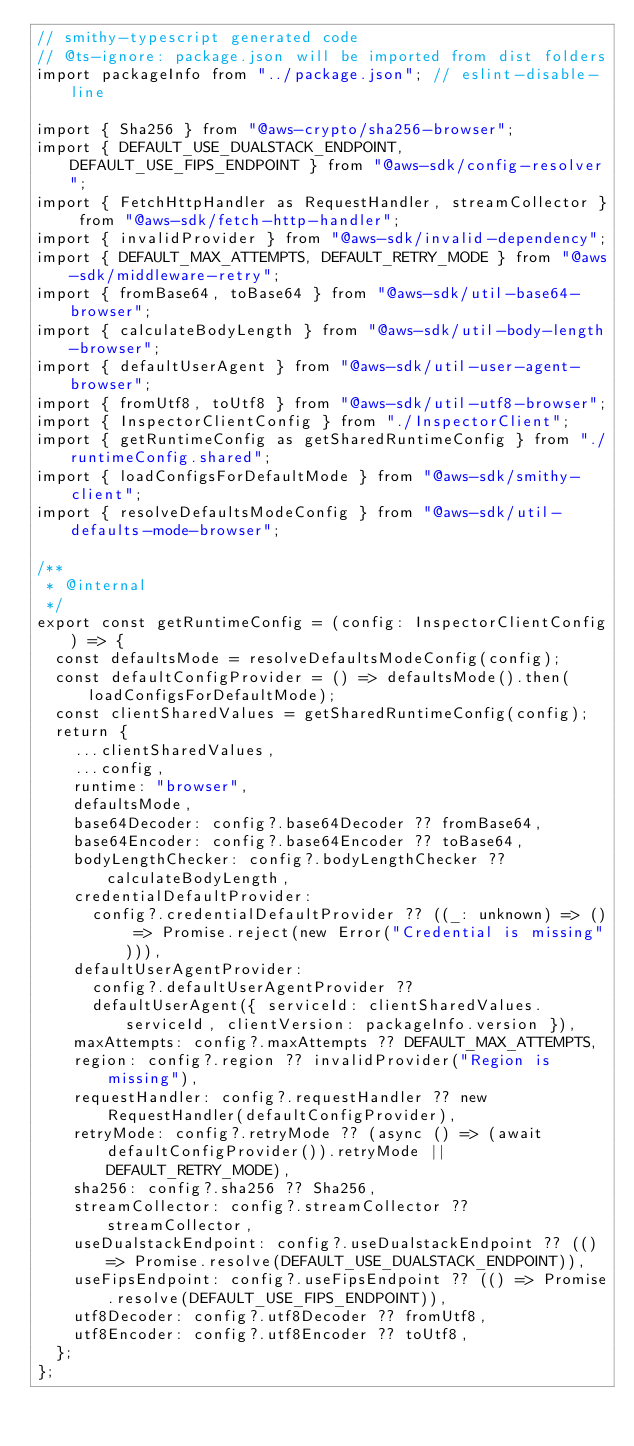<code> <loc_0><loc_0><loc_500><loc_500><_TypeScript_>// smithy-typescript generated code
// @ts-ignore: package.json will be imported from dist folders
import packageInfo from "../package.json"; // eslint-disable-line

import { Sha256 } from "@aws-crypto/sha256-browser";
import { DEFAULT_USE_DUALSTACK_ENDPOINT, DEFAULT_USE_FIPS_ENDPOINT } from "@aws-sdk/config-resolver";
import { FetchHttpHandler as RequestHandler, streamCollector } from "@aws-sdk/fetch-http-handler";
import { invalidProvider } from "@aws-sdk/invalid-dependency";
import { DEFAULT_MAX_ATTEMPTS, DEFAULT_RETRY_MODE } from "@aws-sdk/middleware-retry";
import { fromBase64, toBase64 } from "@aws-sdk/util-base64-browser";
import { calculateBodyLength } from "@aws-sdk/util-body-length-browser";
import { defaultUserAgent } from "@aws-sdk/util-user-agent-browser";
import { fromUtf8, toUtf8 } from "@aws-sdk/util-utf8-browser";
import { InspectorClientConfig } from "./InspectorClient";
import { getRuntimeConfig as getSharedRuntimeConfig } from "./runtimeConfig.shared";
import { loadConfigsForDefaultMode } from "@aws-sdk/smithy-client";
import { resolveDefaultsModeConfig } from "@aws-sdk/util-defaults-mode-browser";

/**
 * @internal
 */
export const getRuntimeConfig = (config: InspectorClientConfig) => {
  const defaultsMode = resolveDefaultsModeConfig(config);
  const defaultConfigProvider = () => defaultsMode().then(loadConfigsForDefaultMode);
  const clientSharedValues = getSharedRuntimeConfig(config);
  return {
    ...clientSharedValues,
    ...config,
    runtime: "browser",
    defaultsMode,
    base64Decoder: config?.base64Decoder ?? fromBase64,
    base64Encoder: config?.base64Encoder ?? toBase64,
    bodyLengthChecker: config?.bodyLengthChecker ?? calculateBodyLength,
    credentialDefaultProvider:
      config?.credentialDefaultProvider ?? ((_: unknown) => () => Promise.reject(new Error("Credential is missing"))),
    defaultUserAgentProvider:
      config?.defaultUserAgentProvider ??
      defaultUserAgent({ serviceId: clientSharedValues.serviceId, clientVersion: packageInfo.version }),
    maxAttempts: config?.maxAttempts ?? DEFAULT_MAX_ATTEMPTS,
    region: config?.region ?? invalidProvider("Region is missing"),
    requestHandler: config?.requestHandler ?? new RequestHandler(defaultConfigProvider),
    retryMode: config?.retryMode ?? (async () => (await defaultConfigProvider()).retryMode || DEFAULT_RETRY_MODE),
    sha256: config?.sha256 ?? Sha256,
    streamCollector: config?.streamCollector ?? streamCollector,
    useDualstackEndpoint: config?.useDualstackEndpoint ?? (() => Promise.resolve(DEFAULT_USE_DUALSTACK_ENDPOINT)),
    useFipsEndpoint: config?.useFipsEndpoint ?? (() => Promise.resolve(DEFAULT_USE_FIPS_ENDPOINT)),
    utf8Decoder: config?.utf8Decoder ?? fromUtf8,
    utf8Encoder: config?.utf8Encoder ?? toUtf8,
  };
};
</code> 